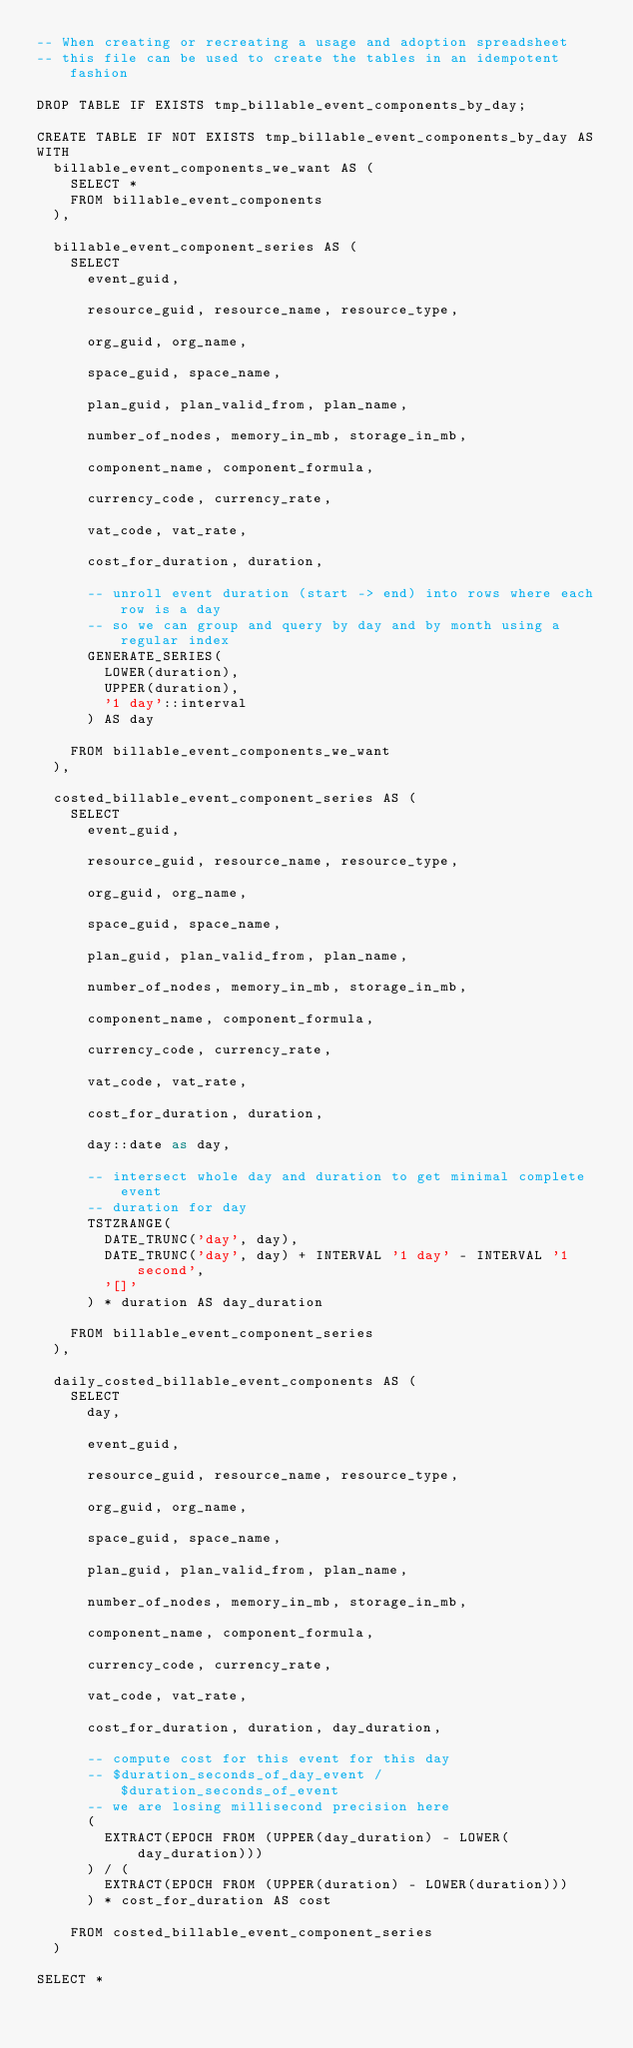Convert code to text. <code><loc_0><loc_0><loc_500><loc_500><_SQL_>-- When creating or recreating a usage and adoption spreadsheet
-- this file can be used to create the tables in an idempotent fashion

DROP TABLE IF EXISTS tmp_billable_event_components_by_day;

CREATE TABLE IF NOT EXISTS tmp_billable_event_components_by_day AS
WITH
  billable_event_components_we_want AS (
    SELECT *
    FROM billable_event_components
  ),

  billable_event_component_series AS (
    SELECT
      event_guid,

      resource_guid, resource_name, resource_type,

      org_guid, org_name,

      space_guid, space_name,

      plan_guid, plan_valid_from, plan_name,

      number_of_nodes, memory_in_mb, storage_in_mb,

      component_name, component_formula,

      currency_code, currency_rate,

      vat_code, vat_rate,

      cost_for_duration, duration,

      -- unroll event duration (start -> end) into rows where each row is a day
      -- so we can group and query by day and by month using a regular index
      GENERATE_SERIES(
        LOWER(duration),
        UPPER(duration),
        '1 day'::interval
      ) AS day

    FROM billable_event_components_we_want
  ),

  costed_billable_event_component_series AS (
    SELECT
      event_guid,

      resource_guid, resource_name, resource_type,

      org_guid, org_name,

      space_guid, space_name,

      plan_guid, plan_valid_from, plan_name,

      number_of_nodes, memory_in_mb, storage_in_mb,

      component_name, component_formula,

      currency_code, currency_rate,

      vat_code, vat_rate,

      cost_for_duration, duration,

      day::date as day,

      -- intersect whole day and duration to get minimal complete event
      -- duration for day
      TSTZRANGE(
        DATE_TRUNC('day', day),
        DATE_TRUNC('day', day) + INTERVAL '1 day' - INTERVAL '1 second',
        '[]'
      ) * duration AS day_duration

    FROM billable_event_component_series
  ),

  daily_costed_billable_event_components AS (
    SELECT
      day,

      event_guid,

      resource_guid, resource_name, resource_type,

      org_guid, org_name,

      space_guid, space_name,

      plan_guid, plan_valid_from, plan_name,

      number_of_nodes, memory_in_mb, storage_in_mb,

      component_name, component_formula,

      currency_code, currency_rate,

      vat_code, vat_rate,

      cost_for_duration, duration, day_duration,

      -- compute cost for this event for this day
      -- $duration_seconds_of_day_event / $duration_seconds_of_event
      -- we are losing millisecond precision here
      (
        EXTRACT(EPOCH FROM (UPPER(day_duration) - LOWER(day_duration)))
      ) / (
        EXTRACT(EPOCH FROM (UPPER(duration) - LOWER(duration)))
      ) * cost_for_duration AS cost

    FROM costed_billable_event_component_series
  )

SELECT *</code> 